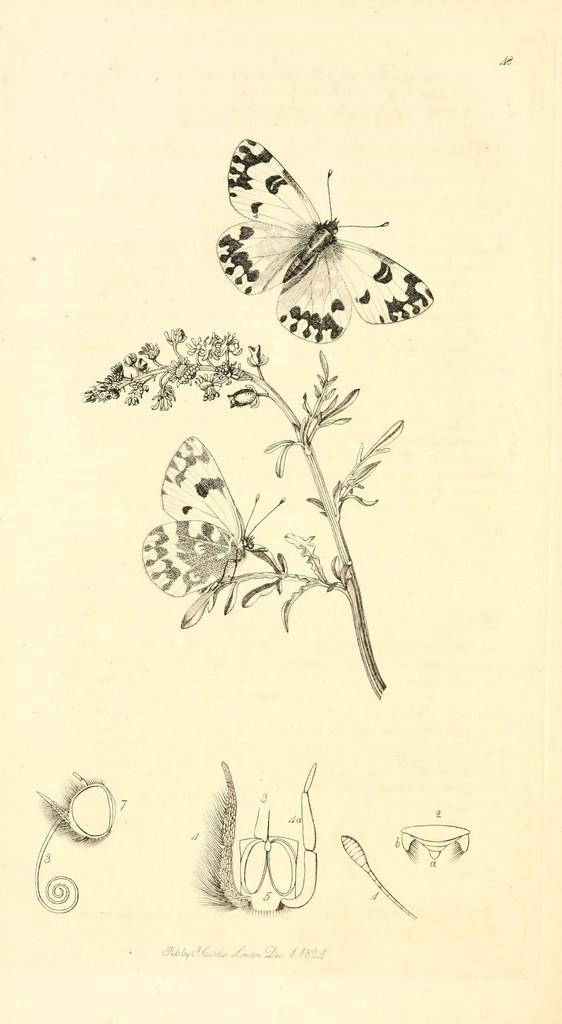What is depicted in the image? There is a drawing in the image. What is included in the drawing? The drawing includes a butterfly. How is the butterfly positioned in the drawing? The butterfly is sitting on a stem in the drawing. Are there any words or letters in the drawing? Yes, there is text written on the drawing. What type of toothpaste is used to clean the butterfly's wings in the image? There is no toothpaste present in the image, and the butterfly is a drawing, not a real insect. 